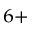<formula> <loc_0><loc_0><loc_500><loc_500>^ { 6 + }</formula> 